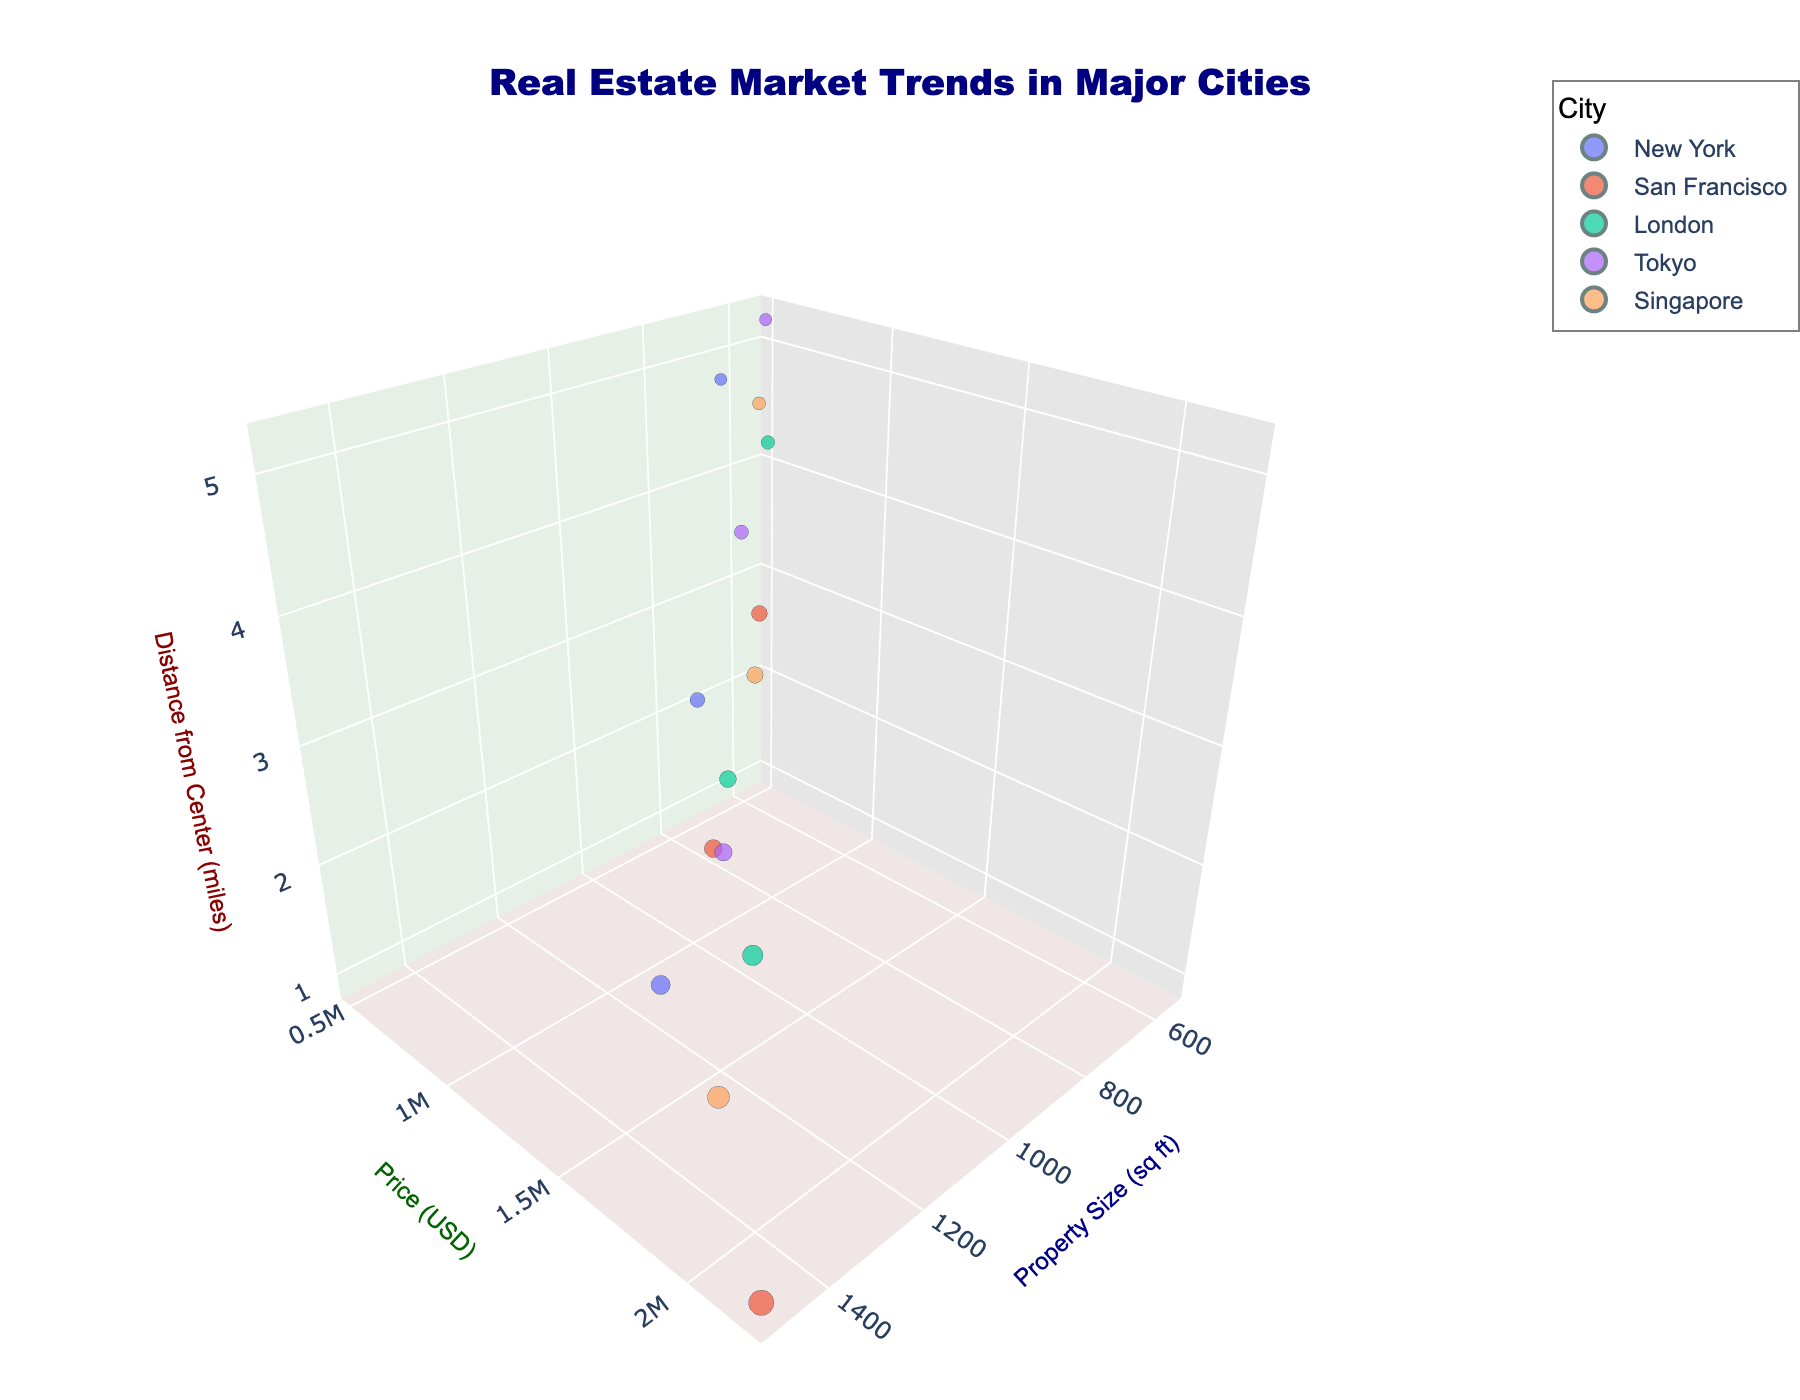What is the title of the plot? The title is located at the top of the figure and provides a summary of what the figure represents.
Answer: Real Estate Market Trends in Major Cities How many different cities are represented in the figure? The colors of the data points represent different cities, and the legend shows the names of these cities. There are five distinct colors representing five cities.
Answer: Five Which city has the highest-priced property? By looking at the y-axis (Price in USD) and identifying the tallest point, the legend can then be used to determine which city it corresponds to.
Answer: San Francisco Comparing New York and Tokyo, which city generally has properties located closer to the city center? By comparing the z-axis (Distance from Center in miles) values for New York and Tokyo, New York's properties are generally closer to the center with most points being at lower values on the z-axis.
Answer: New York What is the property size of the most expensive property? The most expensive property will be the highest point on the y-axis. Reading the corresponding x-axis (Property Size in sq ft) value provides the answer.
Answer: 1500 sqft What is the relationship between property price and distance from the city center in London? By examining the data points for London, an observation can be made about the trend between the y-axis (Price in USD) and the z-axis (Distance from Center in miles). Generally, prices tend to be higher closer to the city center and decrease as the distance increases.
Answer: Prices are higher closer to the center Which city has properties with the largest range in property sizes? By comparing the spread of data points along the x-axis (Property Size in sqft) for each city, San Francisco has the largest range with properties sized between 750 to 1500 sqft.
Answer: San Francisco What is the approximate price of a 700 sqft property in Singapore? Find the data point for Singapore (color-coded) closest to 700 sqft on the x-axis and read its corresponding y-axis value.
Answer: 920,000 USD Comparing property prices in San Francisco versus London, which city has a greater variance in prices? Checking the spread of points along the y-axis (Price in USD) for the data points corresponding to both cities, San Francisco shows a wider range from 850,000 to 2,200,000 USD compared to London's 620,000 to 1,450,000 USD.
Answer: San Francisco On average, are properties more expensive in Tokyo or Singapore? By visually averaging the y-axis values (Price in USD) for data points in Tokyo and Singapore and comparing, Singapore appears to have higher average property prices.
Answer: Singapore 